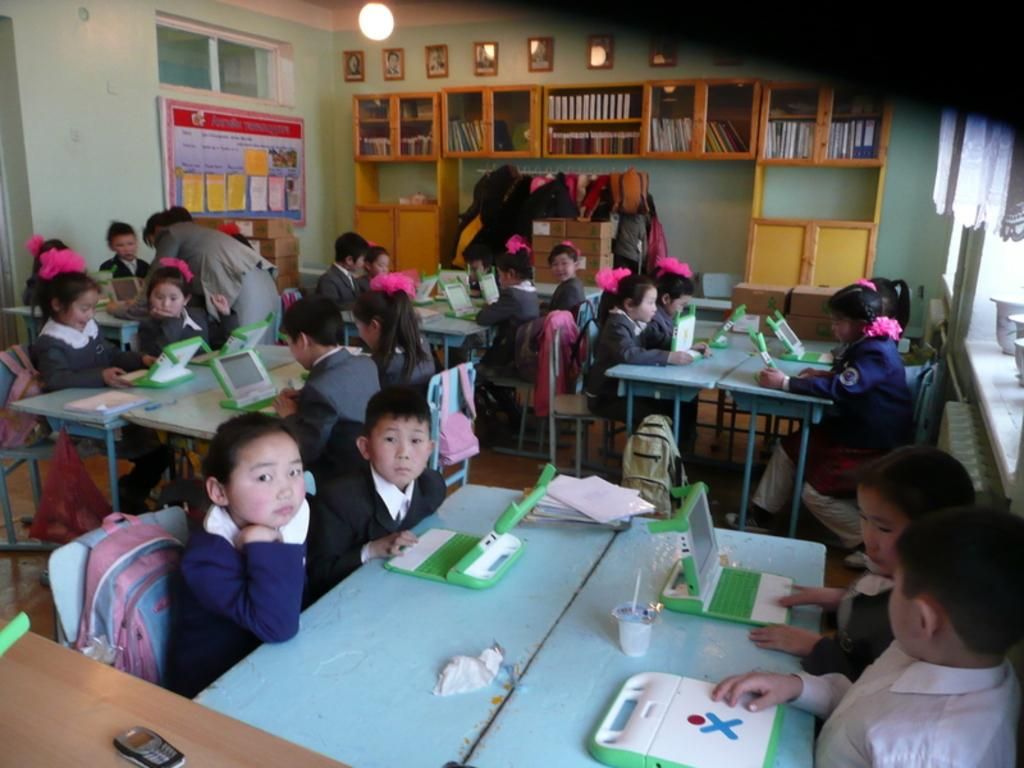What can be seen in the image? There are kids in the image. What are the kids doing in the image? The kids are sitting on chairs. What is in front of the kids? There is a table in front of the kids. What is on the table? There is a laptop on the table. What type of steel is used to make the dolls in the image? There are no dolls present in the image, so the type of steel used to make them cannot be determined. 